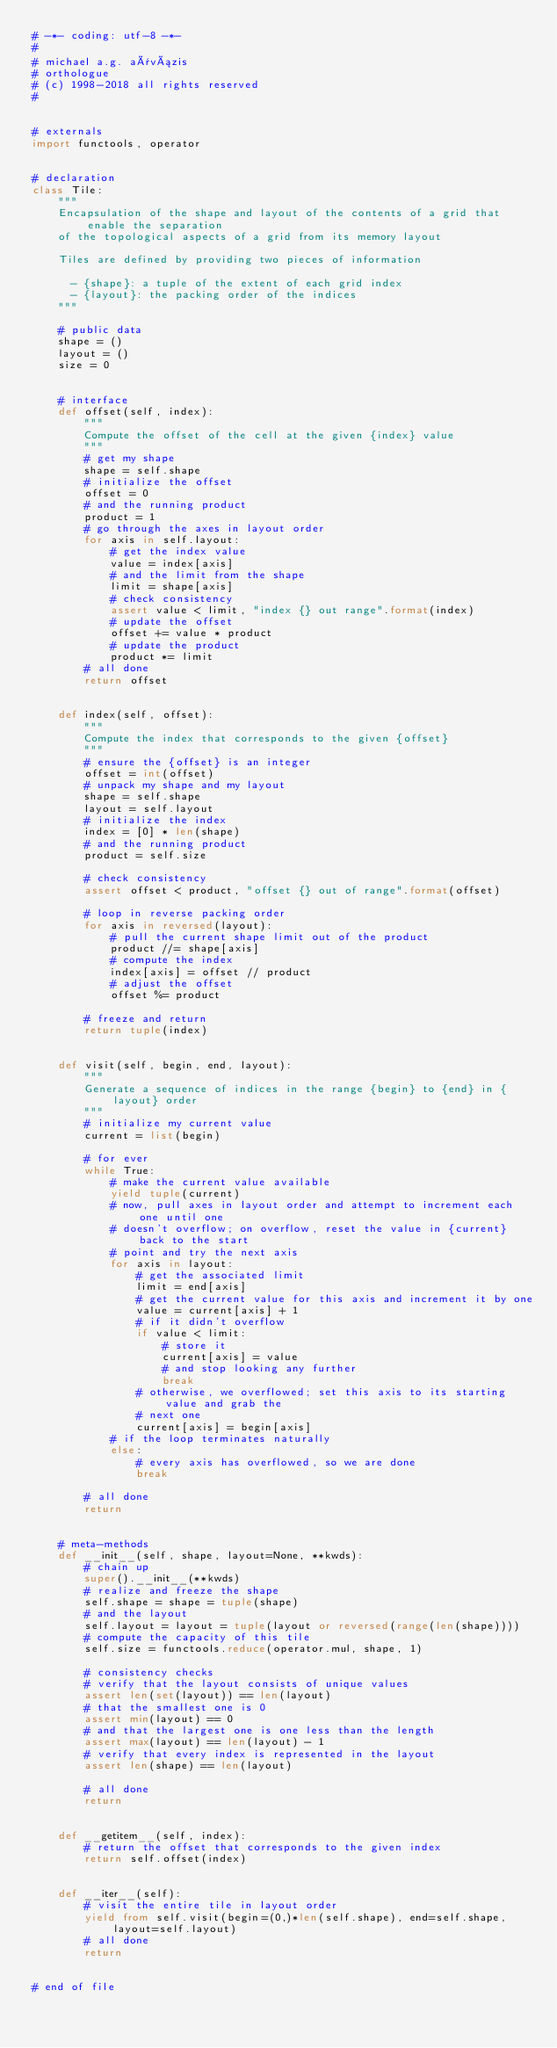<code> <loc_0><loc_0><loc_500><loc_500><_Python_># -*- coding: utf-8 -*-
#
# michael a.g. aïvázis
# orthologue
# (c) 1998-2018 all rights reserved
#


# externals
import functools, operator


# declaration
class Tile:
    """
    Encapsulation of the shape and layout of the contents of a grid that enable the separation
    of the topological aspects of a grid from its memory layout

    Tiles are defined by providing two pieces of information

      - {shape}: a tuple of the extent of each grid index
      - {layout}: the packing order of the indices
    """

    # public data
    shape = ()
    layout = ()
    size = 0


    # interface
    def offset(self, index):
        """
        Compute the offset of the cell at the given {index} value
        """
        # get my shape
        shape = self.shape
        # initialize the offset
        offset = 0
        # and the running product
        product = 1
        # go through the axes in layout order
        for axis in self.layout:
            # get the index value
            value = index[axis]
            # and the limit from the shape
            limit = shape[axis]
            # check consistency
            assert value < limit, "index {} out range".format(index)
            # update the offset
            offset += value * product
            # update the product
            product *= limit
        # all done
        return offset


    def index(self, offset):
        """
        Compute the index that corresponds to the given {offset}
        """
        # ensure the {offset} is an integer
        offset = int(offset)
        # unpack my shape and my layout
        shape = self.shape
        layout = self.layout
        # initialize the index
        index = [0] * len(shape)
        # and the running product
        product = self.size

        # check consistency
        assert offset < product, "offset {} out of range".format(offset)

        # loop in reverse packing order
        for axis in reversed(layout):
            # pull the current shape limit out of the product
            product //= shape[axis]
            # compute the index
            index[axis] = offset // product
            # adjust the offset
            offset %= product

        # freeze and return
        return tuple(index)


    def visit(self, begin, end, layout):
        """
        Generate a sequence of indices in the range {begin} to {end} in {layout} order
        """
        # initialize my current value
        current = list(begin)

        # for ever
        while True:
            # make the current value available
            yield tuple(current)
            # now, pull axes in layout order and attempt to increment each one until one
            # doesn't overflow; on overflow, reset the value in {current} back to the start
            # point and try the next axis
            for axis in layout:
                # get the associated limit
                limit = end[axis]
                # get the current value for this axis and increment it by one
                value = current[axis] + 1
                # if it didn't overflow
                if value < limit:
                    # store it
                    current[axis] = value
                    # and stop looking any further
                    break
                # otherwise, we overflowed; set this axis to its starting value and grab the
                # next one
                current[axis] = begin[axis]
            # if the loop terminates naturally
            else:
                # every axis has overflowed, so we are done
                break

        # all done
        return


    # meta-methods
    def __init__(self, shape, layout=None, **kwds):
        # chain up
        super().__init__(**kwds)
        # realize and freeze the shape
        self.shape = shape = tuple(shape)
        # and the layout
        self.layout = layout = tuple(layout or reversed(range(len(shape))))
        # compute the capacity of this tile
        self.size = functools.reduce(operator.mul, shape, 1)

        # consistency checks
        # verify that the layout consists of unique values
        assert len(set(layout)) == len(layout)
        # that the smallest one is 0
        assert min(layout) == 0
        # and that the largest one is one less than the length
        assert max(layout) == len(layout) - 1
        # verify that every index is represented in the layout
        assert len(shape) == len(layout)

        # all done
        return


    def __getitem__(self, index):
        # return the offset that corresponds to the given index
        return self.offset(index)


    def __iter__(self):
        # visit the entire tile in layout order
        yield from self.visit(begin=(0,)*len(self.shape), end=self.shape, layout=self.layout)
        # all done
        return


# end of file
</code> 